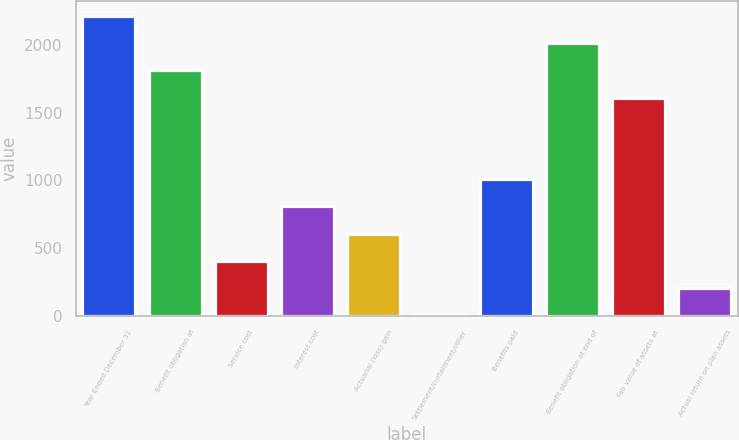Convert chart. <chart><loc_0><loc_0><loc_500><loc_500><bar_chart><fcel>Year Ended December 31<fcel>Benefit obligation at<fcel>Service cost<fcel>Interest cost<fcel>Actuarial (loss) gain<fcel>Settlement/curtailment/other<fcel>Benefits paid<fcel>Benefit obligation at end of<fcel>Fair value of assets at<fcel>Actual return on plan assets<nl><fcel>2217.3<fcel>1814.7<fcel>405.6<fcel>808.2<fcel>606.9<fcel>3<fcel>1009.5<fcel>2016<fcel>1613.4<fcel>204.3<nl></chart> 